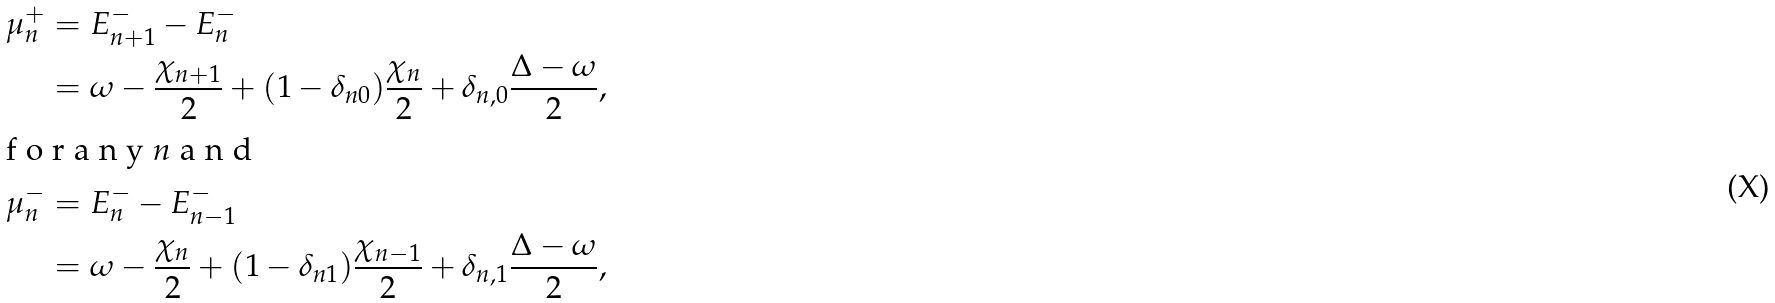<formula> <loc_0><loc_0><loc_500><loc_500>\mu ^ { + } _ { n } & = E ^ { - } _ { n + 1 } - E ^ { - } _ { n } \\ & = \omega - \frac { \chi _ { n + 1 } } 2 + ( 1 - \delta _ { n 0 } ) \frac { \chi _ { n } } 2 + \delta _ { n , 0 } \frac { \Delta - \omega } 2 , \\ \intertext { f o r a n y $ n $ a n d } \mu ^ { - } _ { n } & = E ^ { - } _ { n } - E ^ { - } _ { n - 1 } \\ & = \omega - \frac { \chi _ { n } } 2 + ( 1 - \delta _ { n 1 } ) \frac { \chi _ { n - 1 } } 2 + \delta _ { n , 1 } \frac { \Delta - \omega } 2 ,</formula> 